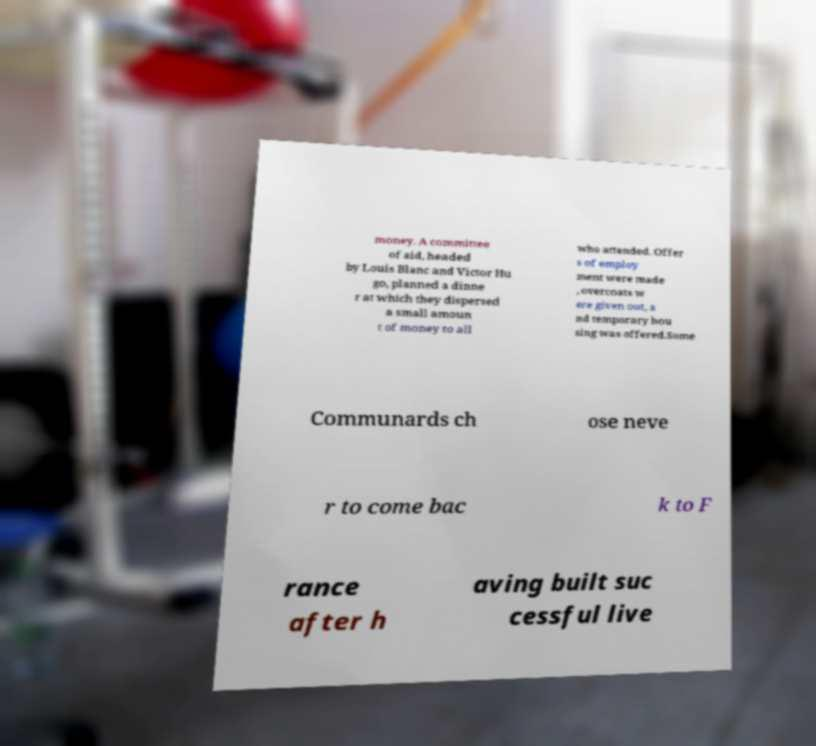What messages or text are displayed in this image? I need them in a readable, typed format. money. A committee of aid, headed by Louis Blanc and Victor Hu go, planned a dinne r at which they dispersed a small amoun t of money to all who attended. Offer s of employ ment were made , overcoats w ere given out, a nd temporary hou sing was offered.Some Communards ch ose neve r to come bac k to F rance after h aving built suc cessful live 